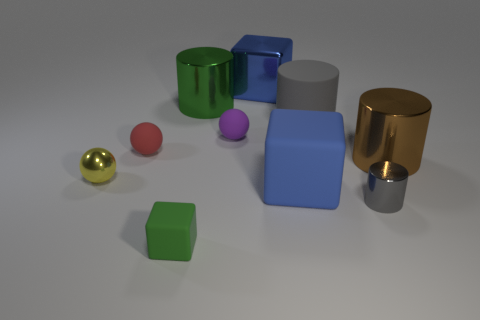Subtract all cylinders. How many objects are left? 6 Subtract 1 green cylinders. How many objects are left? 9 Subtract all tiny shiny cylinders. Subtract all large matte cubes. How many objects are left? 8 Add 1 large cylinders. How many large cylinders are left? 4 Add 8 big blue metallic cubes. How many big blue metallic cubes exist? 9 